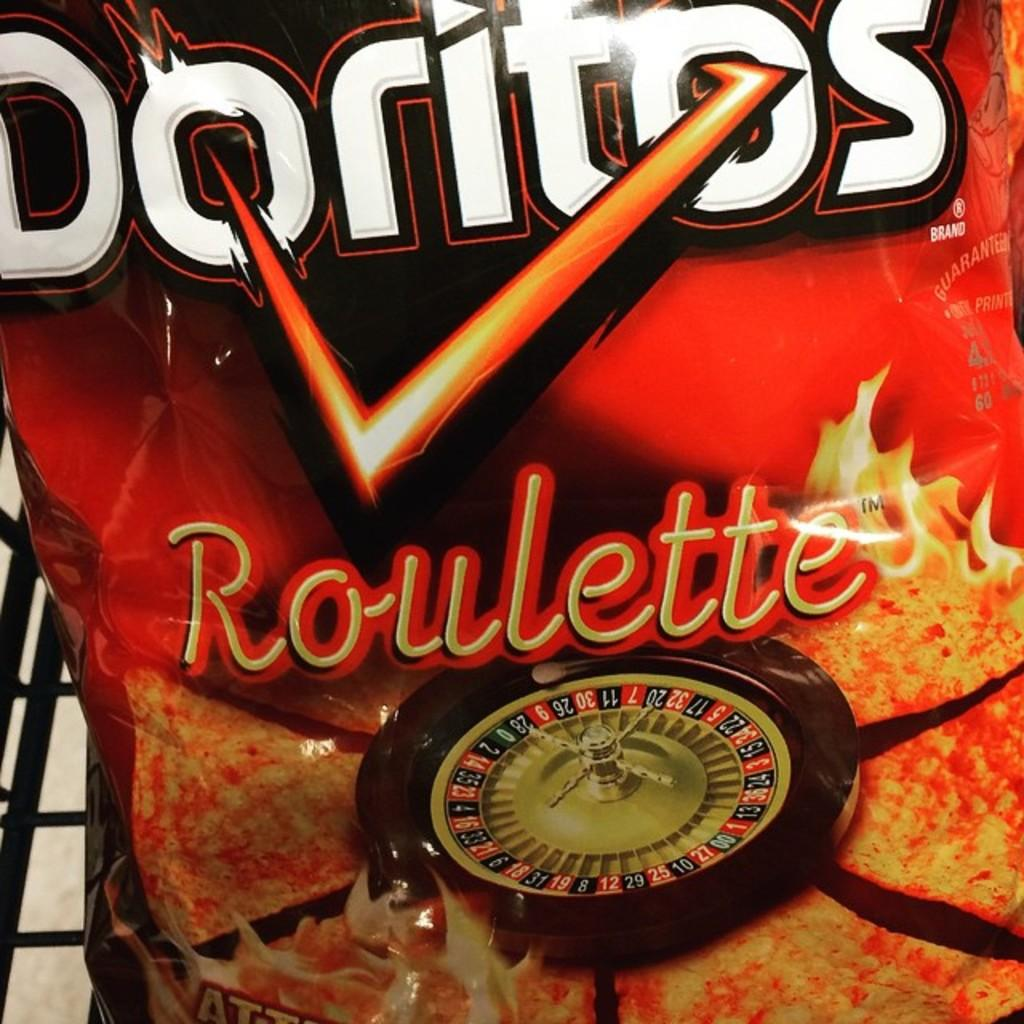What is present in the image related to food packaging? There is a wrapper of a packed food in the image. Can you describe the type of food that might have been in the wrapper? The specific type of food cannot be determined from the image, as only the wrapper is visible. What type of beef can be seen in the cemetery in the image? There is no beef or cemetery present in the image; it only features a wrapper of a packed food. 